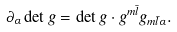<formula> <loc_0><loc_0><loc_500><loc_500>\partial _ { \alpha } \det g = \det g \cdot g ^ { m \bar { l } } g _ { m \bar { l } \alpha } .</formula> 